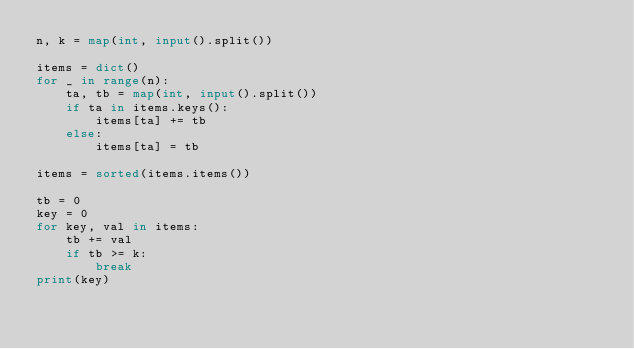Convert code to text. <code><loc_0><loc_0><loc_500><loc_500><_Python_>n, k = map(int, input().split())

items = dict()
for _ in range(n):
    ta, tb = map(int, input().split())
    if ta in items.keys():
        items[ta] += tb
    else:
        items[ta] = tb

items = sorted(items.items())

tb = 0
key = 0
for key, val in items:
    tb += val
    if tb >= k:
        break
print(key)</code> 